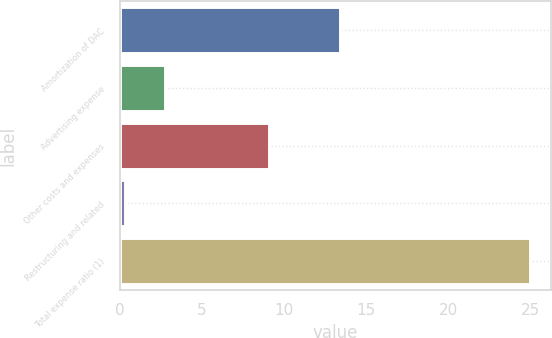Convert chart. <chart><loc_0><loc_0><loc_500><loc_500><bar_chart><fcel>Amortization of DAC<fcel>Advertising expense<fcel>Other costs and expenses<fcel>Restructuring and related<fcel>Total expense ratio (1)<nl><fcel>13.4<fcel>2.77<fcel>9.1<fcel>0.3<fcel>25<nl></chart> 